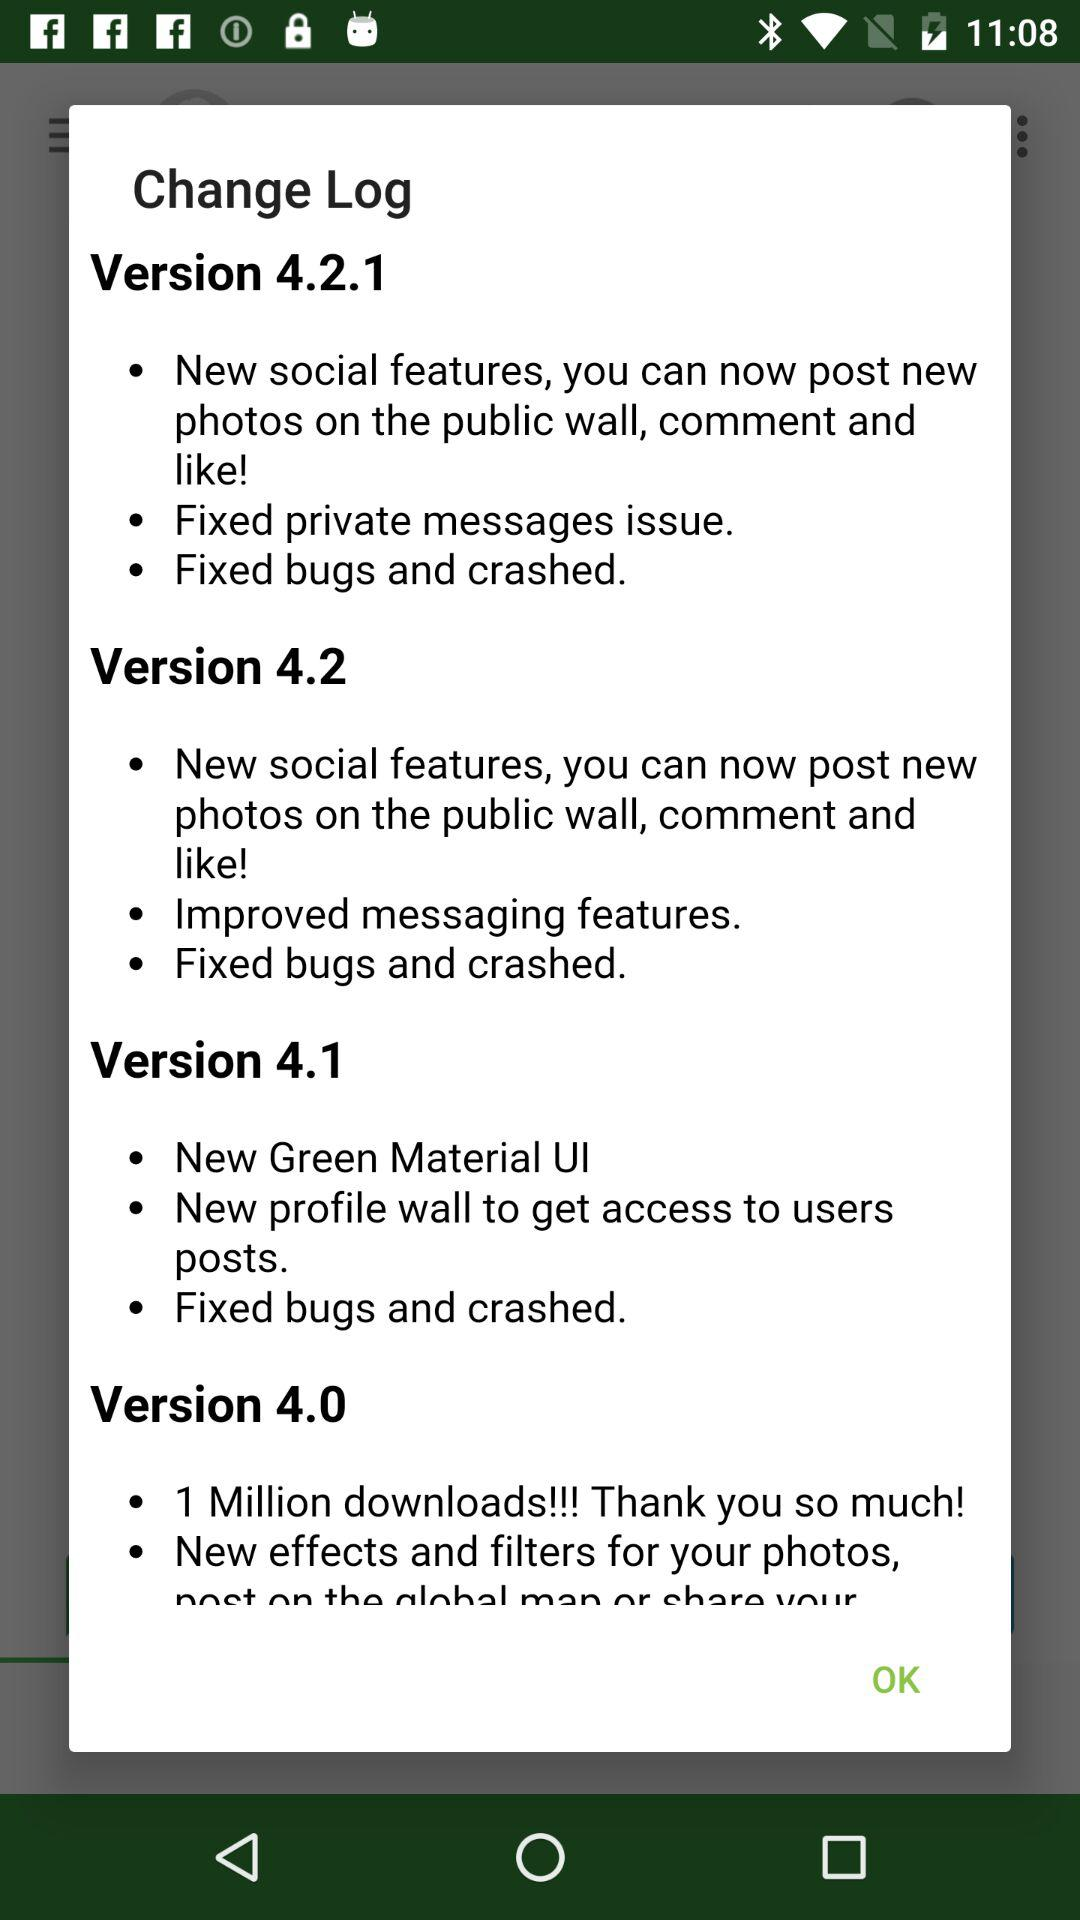How many versions have a bug fix?
Answer the question using a single word or phrase. 3 